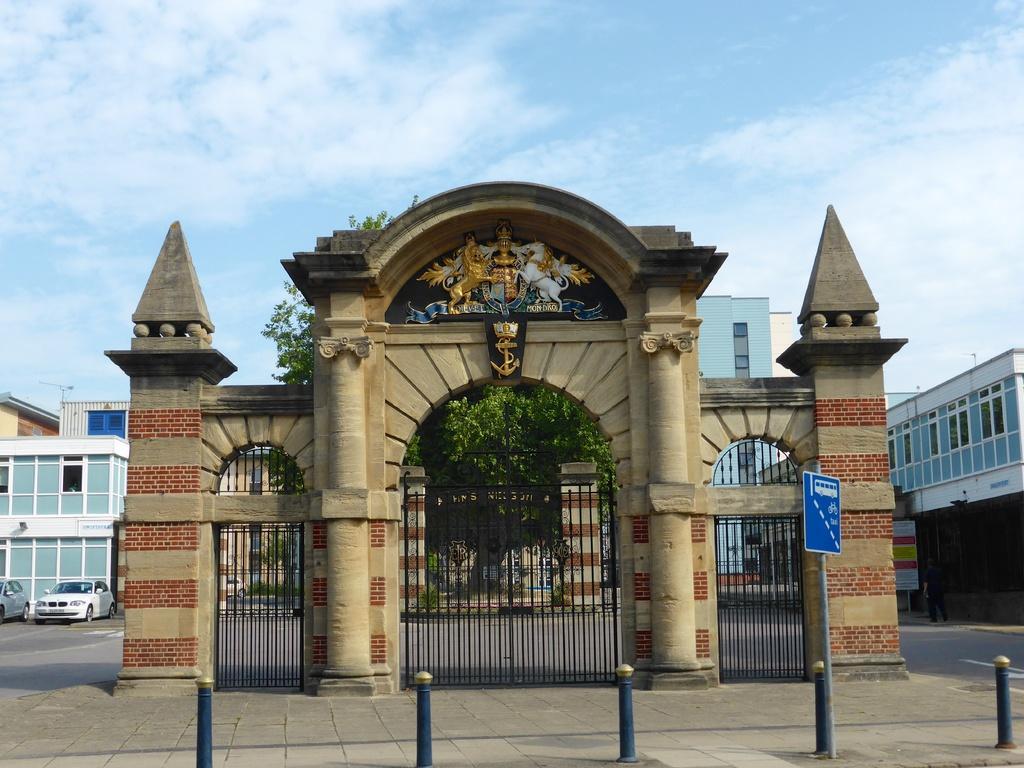Can you describe this image briefly? Here we can see arches, boards, poles and grills. Background there are buildings, vehicles, trees, a person, sky and boards. Sky is cloudy.  